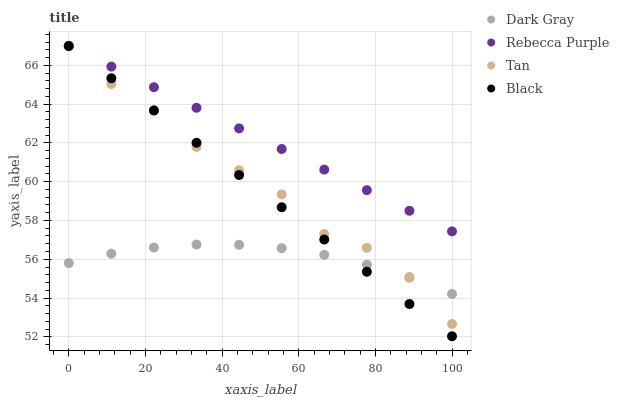Does Dark Gray have the minimum area under the curve?
Answer yes or no. Yes. Does Rebecca Purple have the maximum area under the curve?
Answer yes or no. Yes. Does Tan have the minimum area under the curve?
Answer yes or no. No. Does Tan have the maximum area under the curve?
Answer yes or no. No. Is Rebecca Purple the smoothest?
Answer yes or no. Yes. Is Tan the roughest?
Answer yes or no. Yes. Is Black the smoothest?
Answer yes or no. No. Is Black the roughest?
Answer yes or no. No. Does Black have the lowest value?
Answer yes or no. Yes. Does Tan have the lowest value?
Answer yes or no. No. Does Rebecca Purple have the highest value?
Answer yes or no. Yes. Is Dark Gray less than Rebecca Purple?
Answer yes or no. Yes. Is Rebecca Purple greater than Dark Gray?
Answer yes or no. Yes. Does Tan intersect Dark Gray?
Answer yes or no. Yes. Is Tan less than Dark Gray?
Answer yes or no. No. Is Tan greater than Dark Gray?
Answer yes or no. No. Does Dark Gray intersect Rebecca Purple?
Answer yes or no. No. 